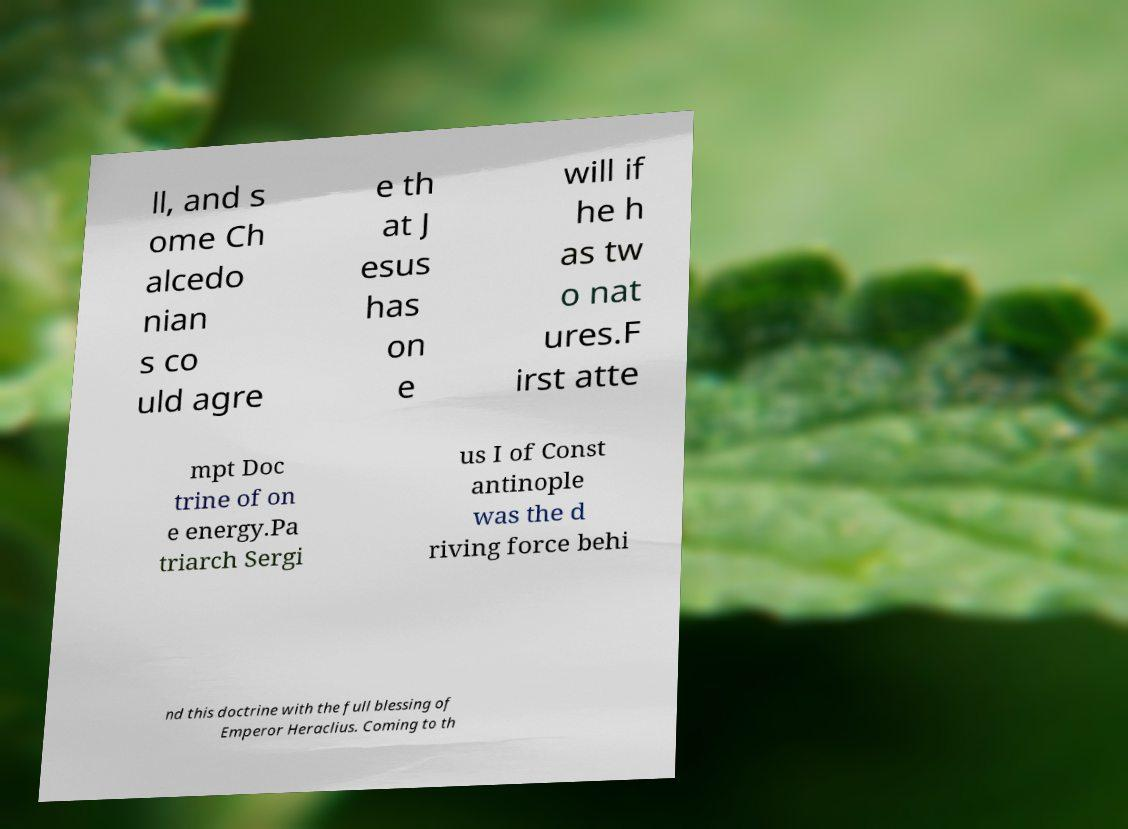For documentation purposes, I need the text within this image transcribed. Could you provide that? ll, and s ome Ch alcedo nian s co uld agre e th at J esus has on e will if he h as tw o nat ures.F irst atte mpt Doc trine of on e energy.Pa triarch Sergi us I of Const antinople was the d riving force behi nd this doctrine with the full blessing of Emperor Heraclius. Coming to th 